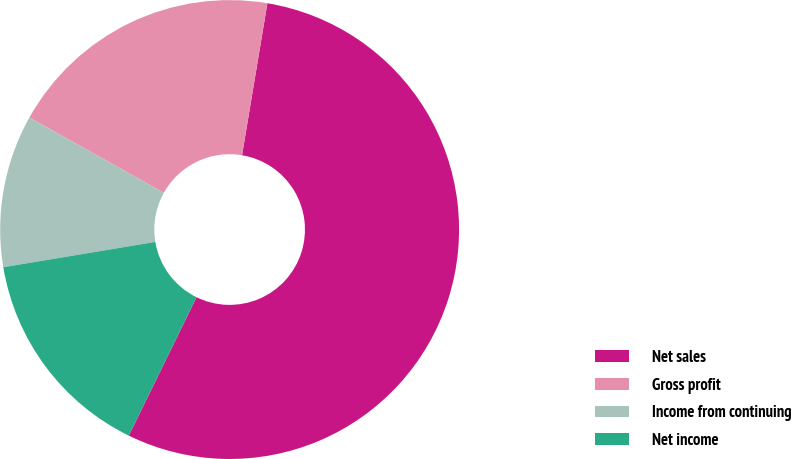<chart> <loc_0><loc_0><loc_500><loc_500><pie_chart><fcel>Net sales<fcel>Gross profit<fcel>Income from continuing<fcel>Net income<nl><fcel>54.61%<fcel>19.52%<fcel>10.74%<fcel>15.13%<nl></chart> 